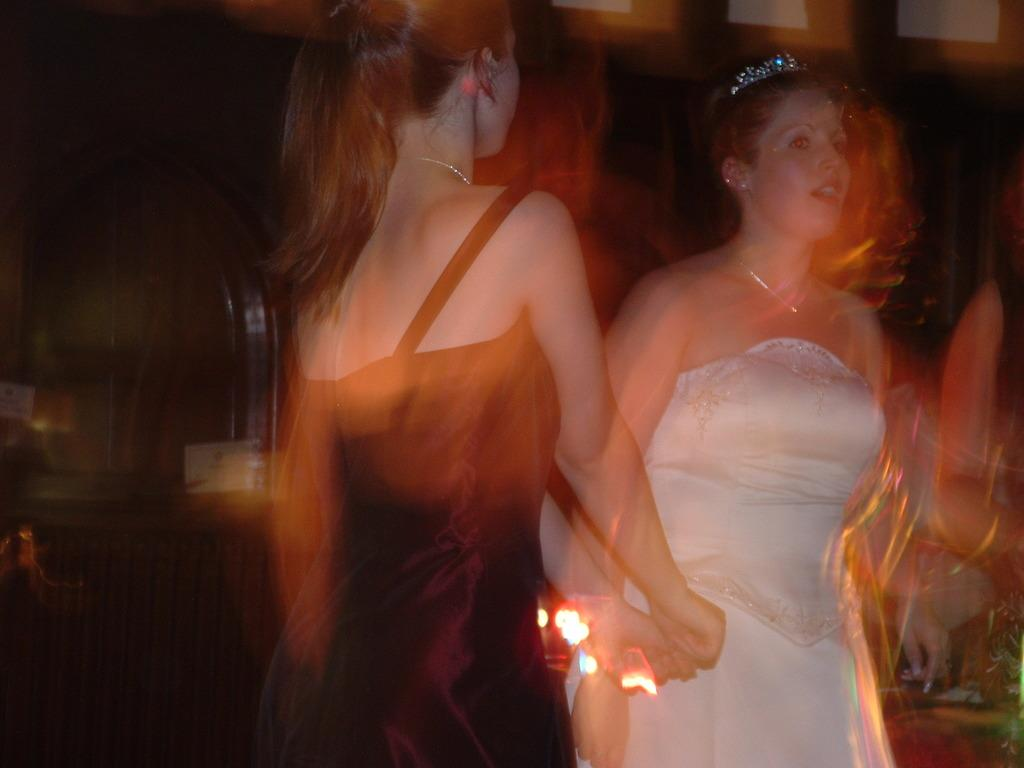How many women are in the image? There are two women in the image. What colors are the dresses worn by the women? One woman is wearing a white dress, and the other woman is wearing a black dress. Can you describe the background of the image? The background of the image is blurry. Are there any snails or monkeys present in the image? No, there are no snails or monkeys present in the image. 